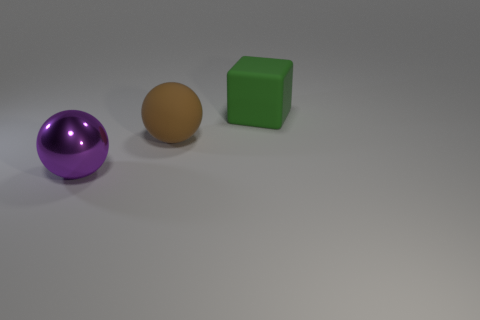Does the matte thing in front of the block have the same size as the object that is right of the large brown matte ball?
Your response must be concise. Yes. What is the shape of the other object that is the same material as the brown object?
Ensure brevity in your answer.  Cube. Are there any other things that are the same shape as the large metallic object?
Make the answer very short. Yes. The big sphere that is on the right side of the large sphere that is in front of the rubber thing that is in front of the matte block is what color?
Your answer should be compact. Brown. Are there fewer large things in front of the brown ball than big purple shiny objects to the right of the big green matte cube?
Keep it short and to the point. No. Does the purple thing have the same shape as the green thing?
Your answer should be compact. No. What number of brown matte spheres are the same size as the brown rubber object?
Keep it short and to the point. 0. Is the number of green matte objects that are to the left of the large green matte block less than the number of small gray blocks?
Your answer should be compact. No. There is a object that is behind the big matte thing that is to the left of the large green matte object; what is its size?
Your answer should be very brief. Large. How many things are either big purple balls or brown spheres?
Give a very brief answer. 2. 